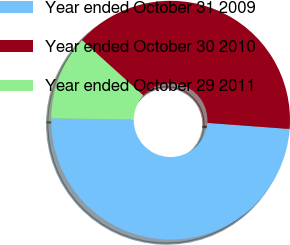Convert chart to OTSL. <chart><loc_0><loc_0><loc_500><loc_500><pie_chart><fcel>Year ended October 31 2009<fcel>Year ended October 30 2010<fcel>Year ended October 29 2011<nl><fcel>49.08%<fcel>39.48%<fcel>11.44%<nl></chart> 